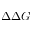<formula> <loc_0><loc_0><loc_500><loc_500>\Delta \Delta G</formula> 